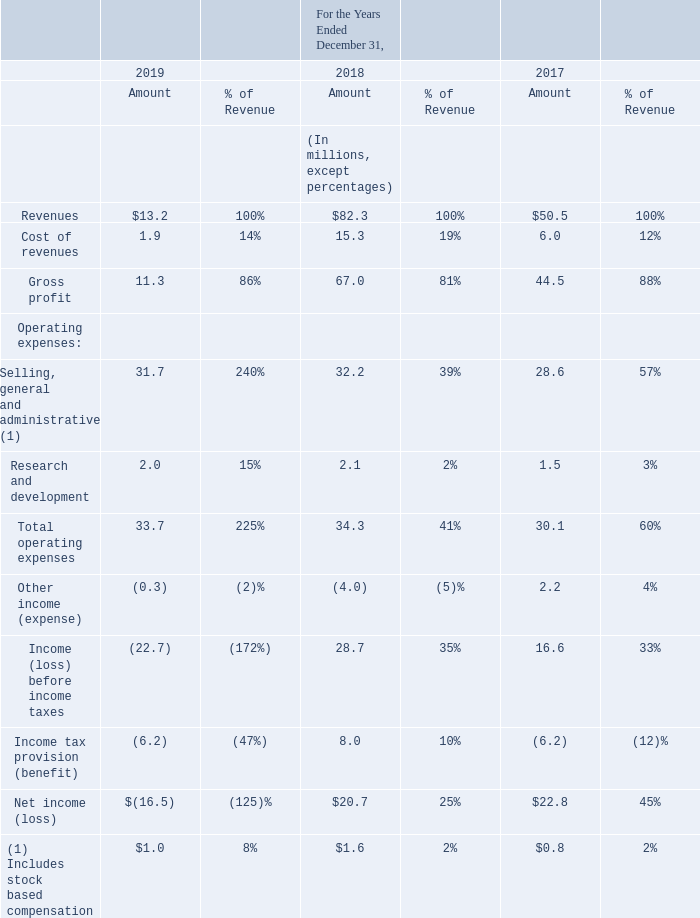Results of Operations
We operate a cybersecurity business, focused on licensing and enforcement, providing advisory services, developing mobile security applications, and investing in emerging cybersecurity technologies and intellectual property. The following table summarizes our results of operations for the periods presented and as a percentage of our total revenue for those periods based on our consolidated statement of operations data. The year to year comparison of results of operations is not necessarily indicative of results of operations for future periods.
What are the respective revenues from operations in 2018 and 2019 respectively?
Answer scale should be: million. $82.3, $13.2. What are the respective cost of revenues from operations in 2018 and 2019 respectively?
Answer scale should be: million. 15.3, 1.9. What are the respective gross profit from operations in 2018 and 2019 respectively?
Answer scale should be: million. 67.0, 11.3. What is the average revenue between 2017 to 2019?
Answer scale should be: million. (50.5 + 82.3 + 13.2)/3 
Answer: 48.67. What is the percentage change in cost of revenue between 2017 and 2018?
Answer scale should be: percent. (15.3-6)/6 
Answer: 155. What is the percentage change in gross profit between 2018 and 2019?
Answer scale should be: percent. (11.3-67)/67 
Answer: -83.13. 